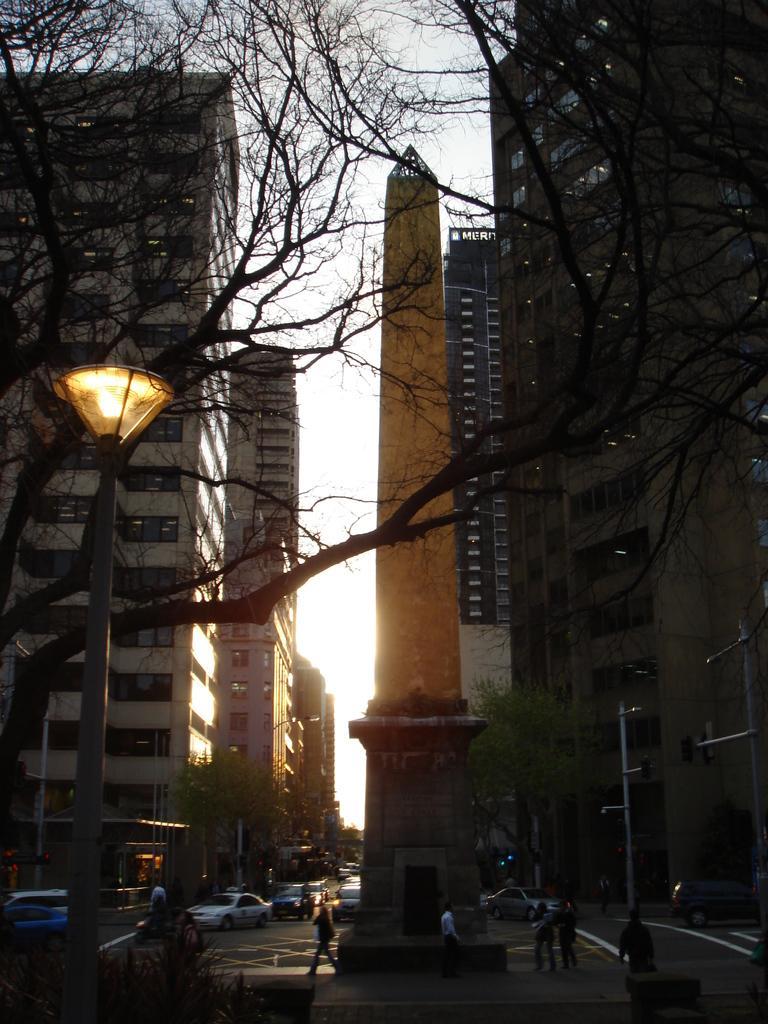Describe this image in one or two sentences. In this image I can see few people walking, few vehicles, light poles, trees. In the background I can see few buildings and the sky is in white color. 